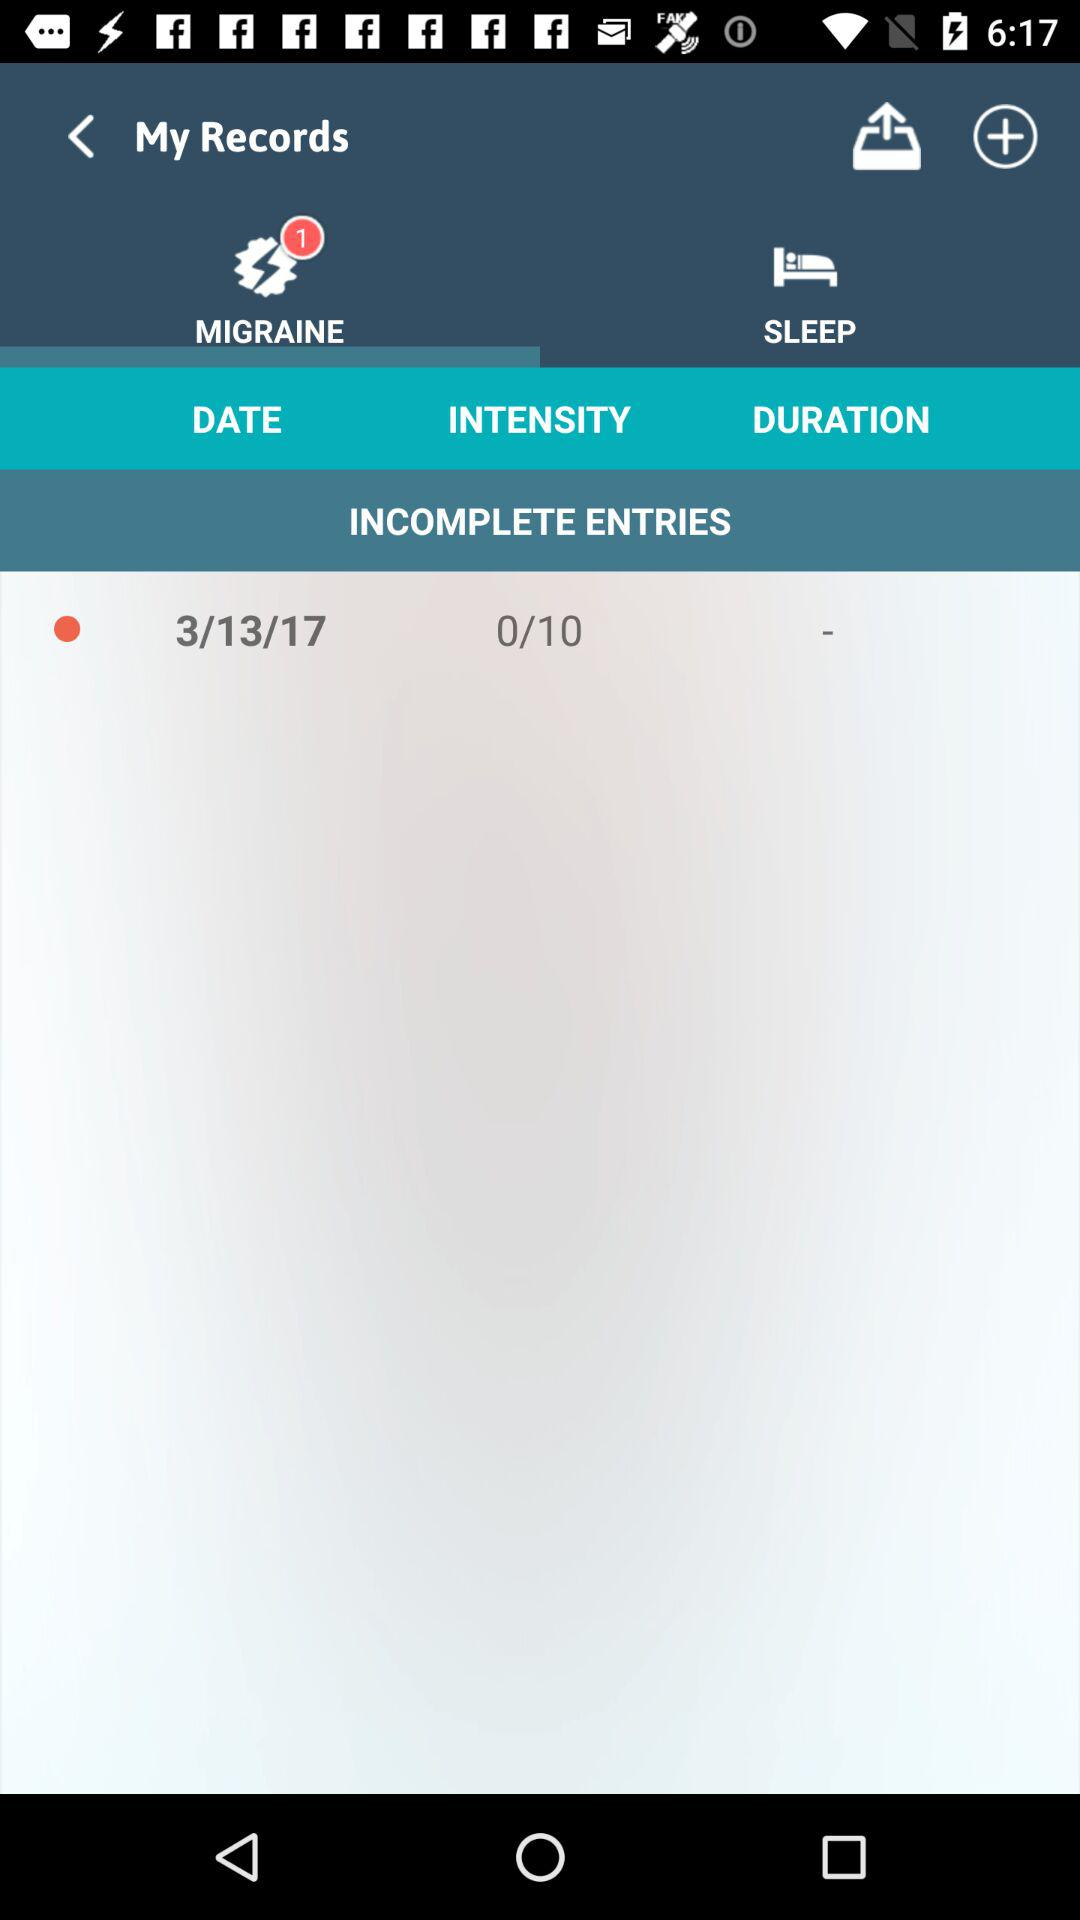What is the date of the incomplete entries? The date of the incomplete entries is 3/13/17. 